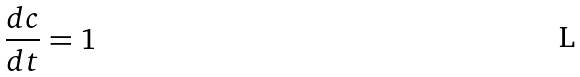Convert formula to latex. <formula><loc_0><loc_0><loc_500><loc_500>\frac { d c } { d t } = 1</formula> 